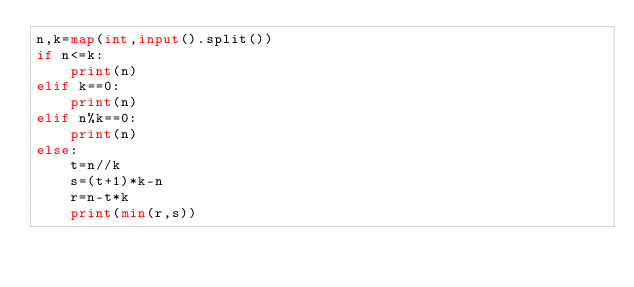<code> <loc_0><loc_0><loc_500><loc_500><_Python_>n,k=map(int,input().split())
if n<=k:
    print(n)
elif k==0:
    print(n)
elif n%k==0:
    print(n)
else:
    t=n//k
    s=(t+1)*k-n
    r=n-t*k
    print(min(r,s))</code> 